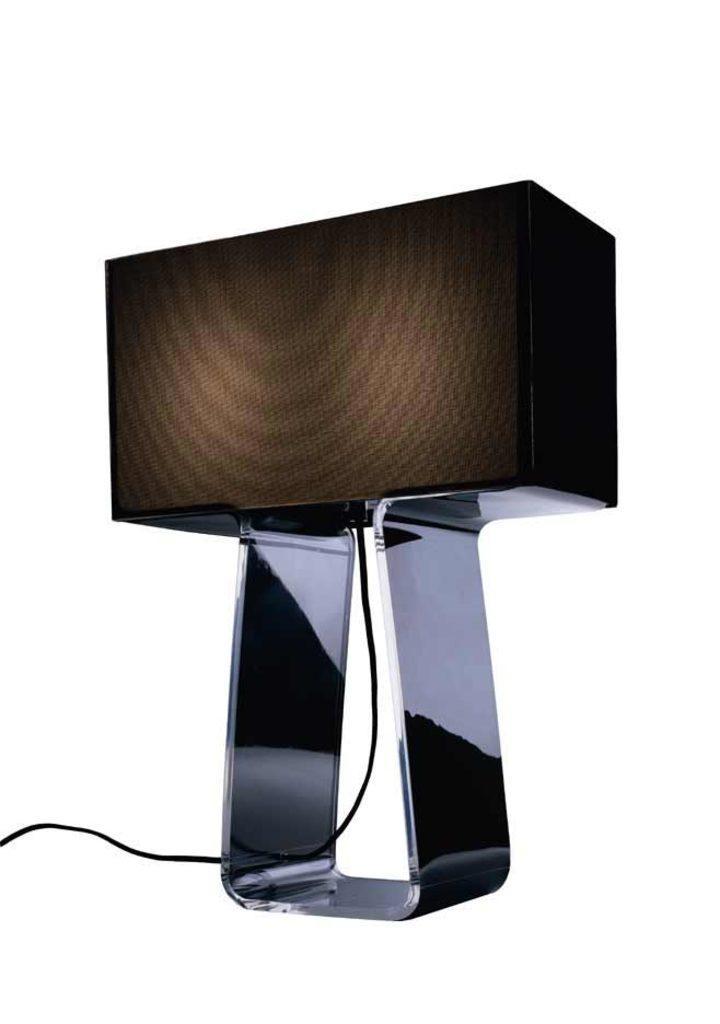Can you describe this image briefly? In the picture we can see a metal with a stand and wire to it. 